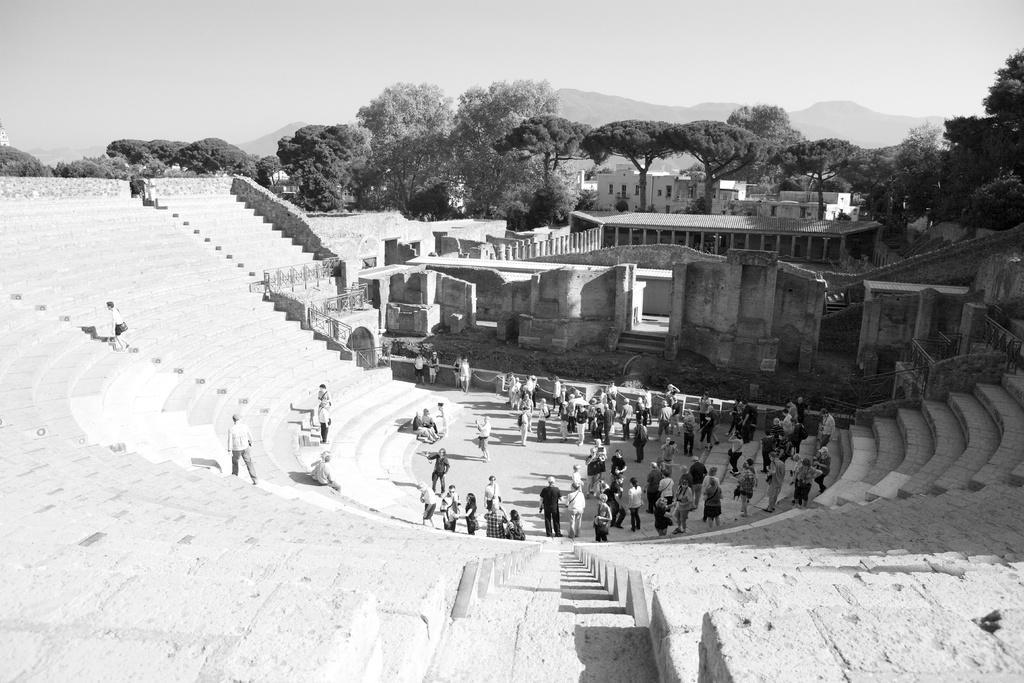Please provide a concise description of this image. This is a black and white image. I can see groups of people standing and few people sitting on the stairs. There are trees and buildings. In the background, I can see hills and there is the sky. 